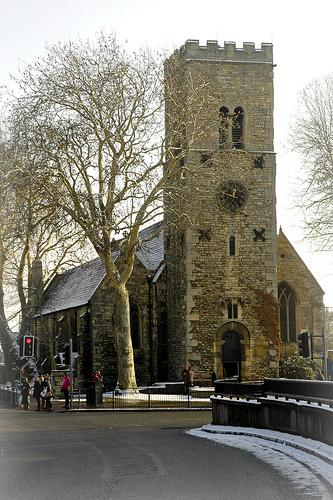Question: why are the people stopped?
Choices:
A. Looking at the wreck that occurred.
B. Waiting for the light to change.
C. Playing a game with the children.
D. Waiting for the toll bridge to come down.
Answer with the letter. Answer: B Question: who is pictured?
Choices:
A. Pedestrians.
B. Drivers.
C. Hitch hikers.
D. Runners.
Answer with the letter. Answer: A Question: where are they located?
Choices:
A. Inside the airport.
B. Outside of a church.
C. In front of the court house.
D. At the high school.
Answer with the letter. Answer: B Question: how many churches are pictured?
Choices:
A. 1.
B. 2.
C. 3.
D. 4.
Answer with the letter. Answer: A Question: what color is the street?
Choices:
A. Gray.
B. Black.
C. Yellow.
D. Red.
Answer with the letter. Answer: B Question: when was the photo taken?
Choices:
A. Spring time.
B. Summer time.
C. Winter time.
D. Autumn time.
Answer with the letter. Answer: C 